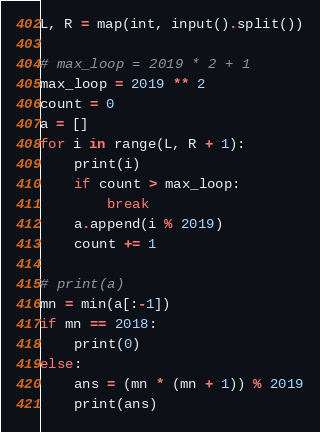<code> <loc_0><loc_0><loc_500><loc_500><_Python_>L, R = map(int, input().split())

# max_loop = 2019 * 2 + 1
max_loop = 2019 ** 2
count = 0
a = []
for i in range(L, R + 1):
    print(i)
    if count > max_loop:
        break
    a.append(i % 2019)
    count += 1

# print(a)
mn = min(a[:-1])
if mn == 2018:
    print(0)
else:
    ans = (mn * (mn + 1)) % 2019
    print(ans)
</code> 